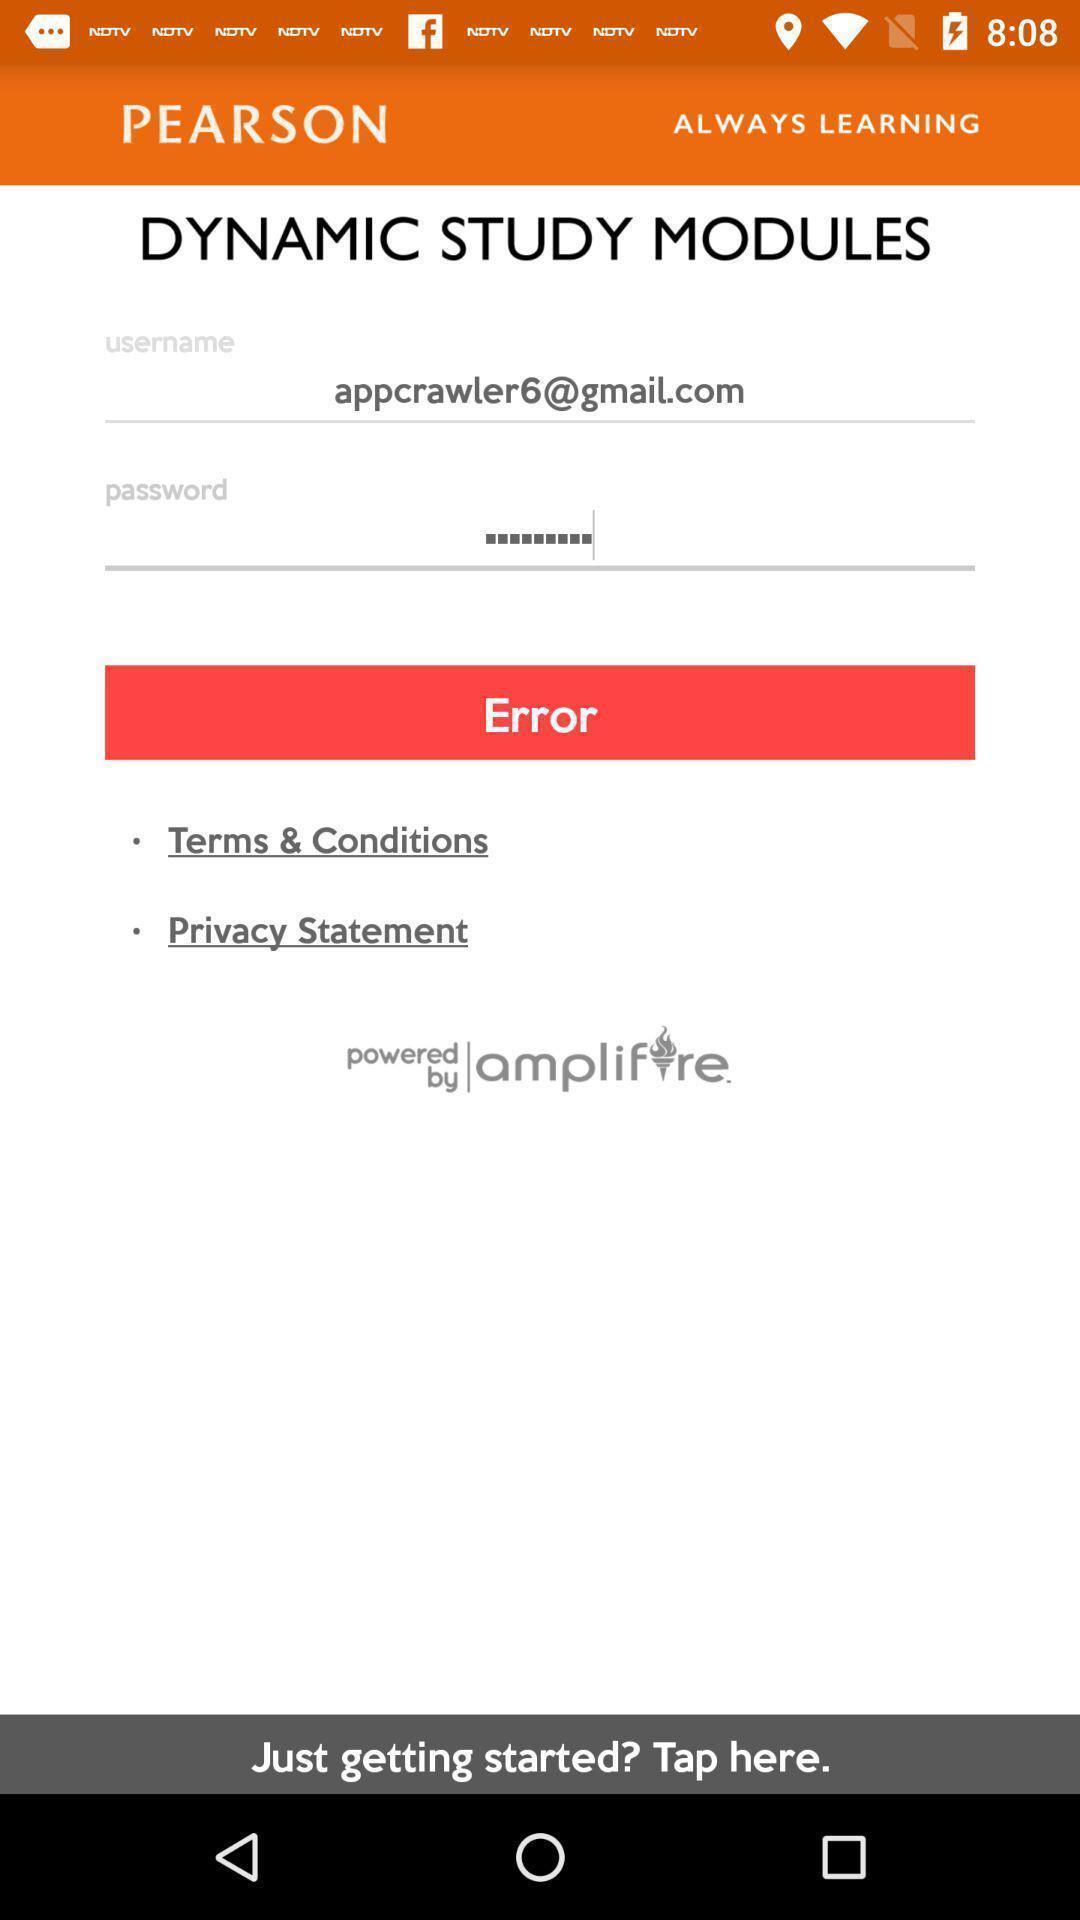Provide a textual representation of this image. Page showing option like error. 